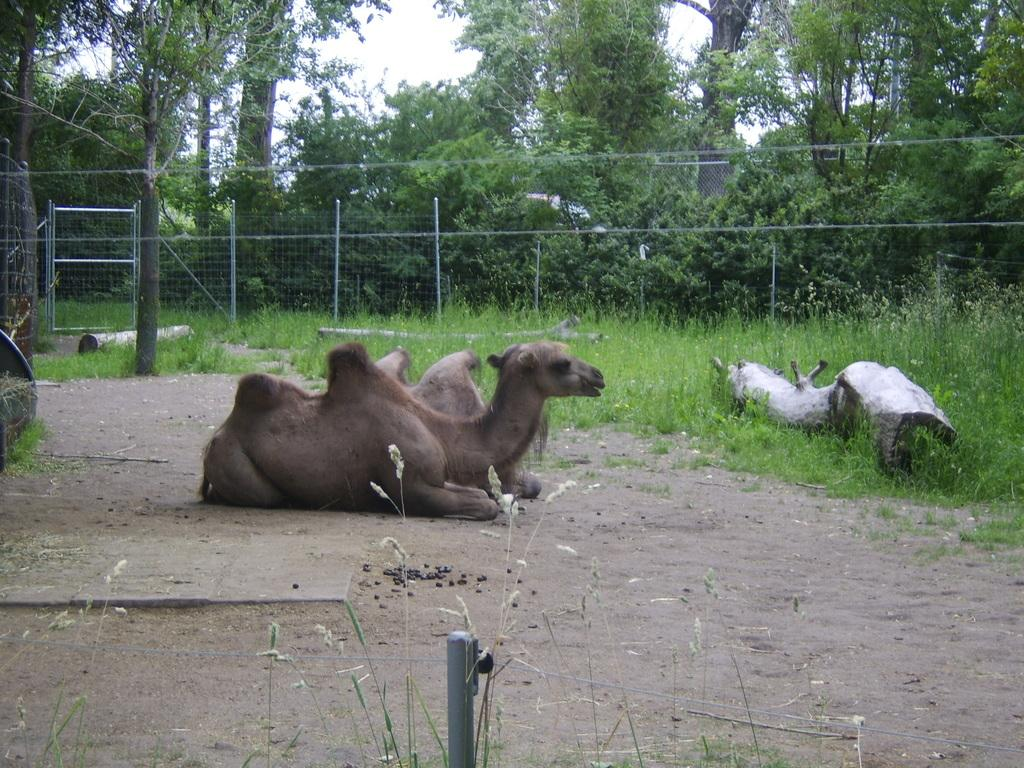What animals are sitting on the ground in the center of the image? There are camels sitting on the ground in the center of the image. What type of vegetation can be seen in the background of the image? There is grass in the background of the image. What architectural feature is visible in the background of the image? There is fencing in the background of the image. What else can be seen in the background of the image? There are trees and the sky visible in the background of the image. How many sisters are sitting with the camels in the image? There are no sisters present in the image; it features camels sitting on the ground. What color are the cats in the image? There are no cats present in the image. 